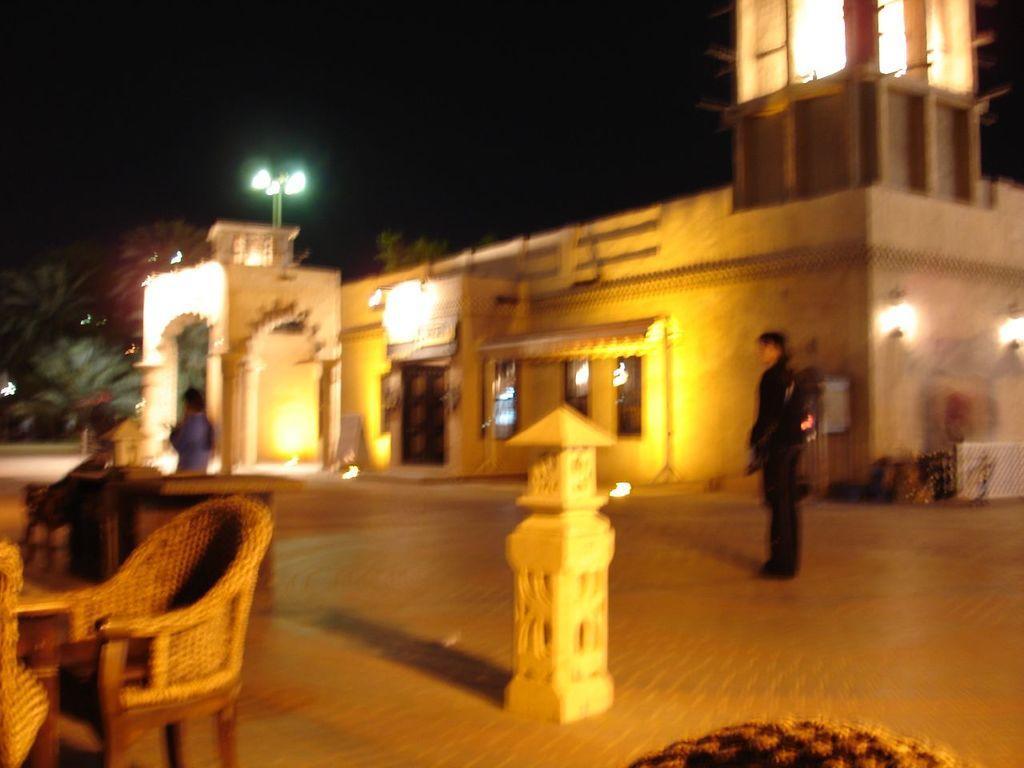Could you give a brief overview of what you see in this image? In this image we can see two persons. Behind the persons we can see a building. On the building we can see few lights. On the left side, we can see few trees. In front of the persons we can see few chairs and tables. 